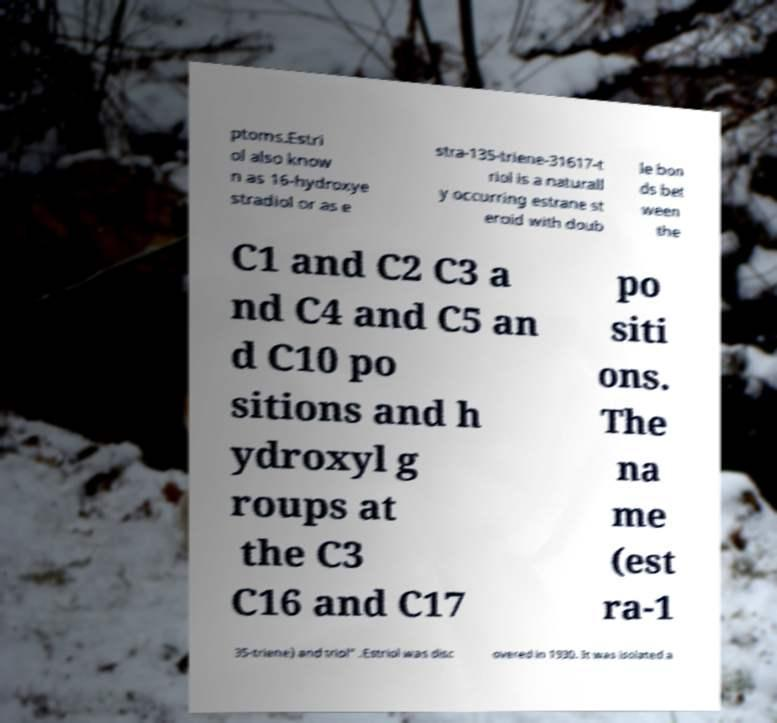Can you accurately transcribe the text from the provided image for me? ptoms.Estri ol also know n as 16-hydroxye stradiol or as e stra-135-triene-31617-t riol is a naturall y occurring estrane st eroid with doub le bon ds bet ween the C1 and C2 C3 a nd C4 and C5 an d C10 po sitions and h ydroxyl g roups at the C3 C16 and C17 po siti ons. The na me (est ra-1 35-triene) and triol" .Estriol was disc overed in 1930. It was isolated a 